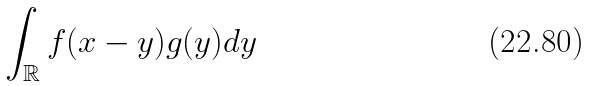Convert formula to latex. <formula><loc_0><loc_0><loc_500><loc_500>\int _ { \mathbb { R } } f ( x - y ) g ( y ) d y</formula> 